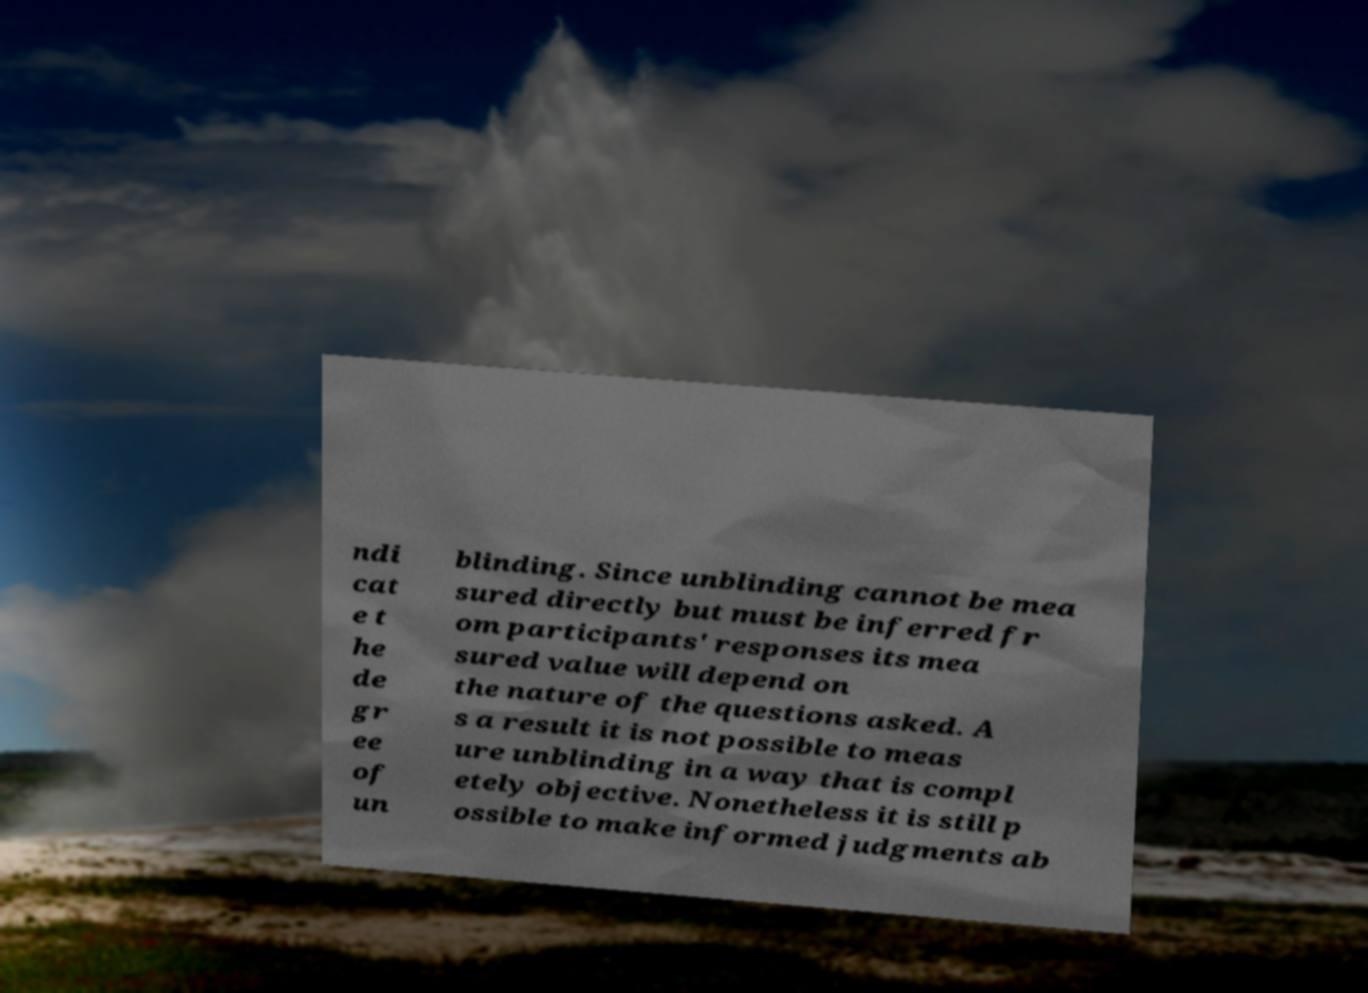Please identify and transcribe the text found in this image. ndi cat e t he de gr ee of un blinding. Since unblinding cannot be mea sured directly but must be inferred fr om participants' responses its mea sured value will depend on the nature of the questions asked. A s a result it is not possible to meas ure unblinding in a way that is compl etely objective. Nonetheless it is still p ossible to make informed judgments ab 